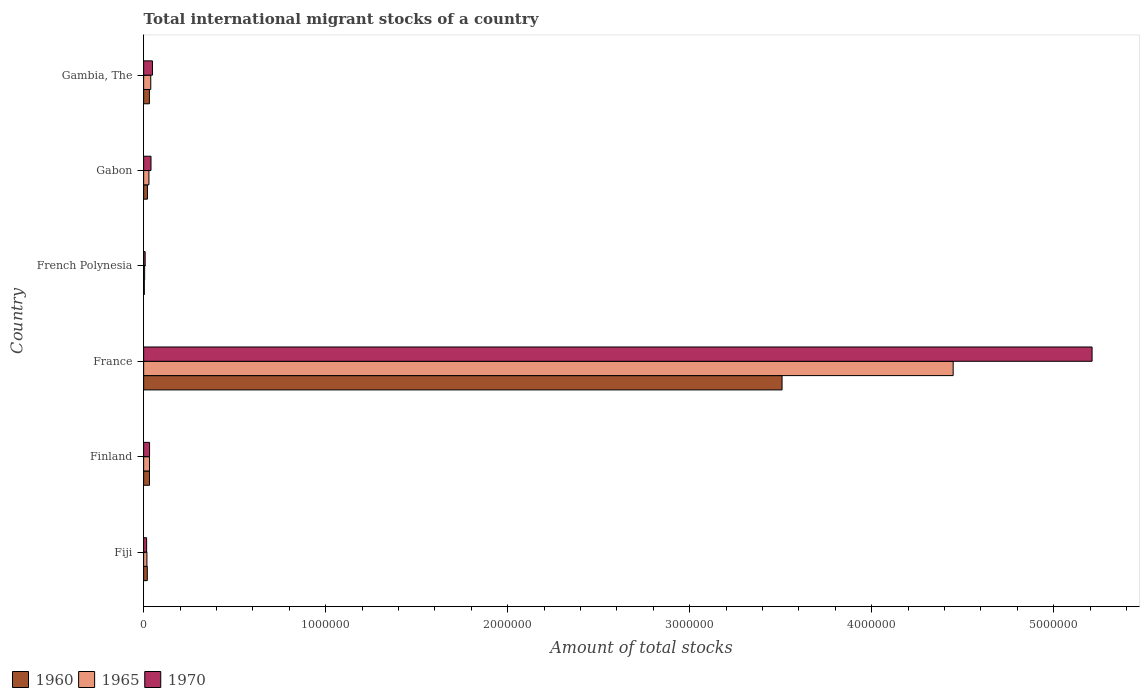How many groups of bars are there?
Ensure brevity in your answer.  6. How many bars are there on the 4th tick from the bottom?
Provide a succinct answer. 3. What is the label of the 6th group of bars from the top?
Offer a very short reply. Fiji. In how many cases, is the number of bars for a given country not equal to the number of legend labels?
Your response must be concise. 0. What is the amount of total stocks in in 1970 in Gabon?
Your answer should be very brief. 4.04e+04. Across all countries, what is the maximum amount of total stocks in in 1965?
Offer a terse response. 4.45e+06. Across all countries, what is the minimum amount of total stocks in in 1970?
Provide a succinct answer. 8194. In which country was the amount of total stocks in in 1960 maximum?
Make the answer very short. France. In which country was the amount of total stocks in in 1970 minimum?
Keep it short and to the point. French Polynesia. What is the total amount of total stocks in in 1965 in the graph?
Give a very brief answer. 4.57e+06. What is the difference between the amount of total stocks in in 1970 in Fiji and that in French Polynesia?
Make the answer very short. 8200. What is the difference between the amount of total stocks in in 1960 in Finland and the amount of total stocks in in 1970 in France?
Offer a very short reply. -5.18e+06. What is the average amount of total stocks in in 1965 per country?
Provide a short and direct response. 7.62e+05. What is the difference between the amount of total stocks in in 1965 and amount of total stocks in in 1960 in Finland?
Your answer should be very brief. 112. What is the ratio of the amount of total stocks in in 1965 in France to that in French Polynesia?
Provide a short and direct response. 811.54. Is the difference between the amount of total stocks in in 1965 in Fiji and Finland greater than the difference between the amount of total stocks in in 1960 in Fiji and Finland?
Keep it short and to the point. No. What is the difference between the highest and the second highest amount of total stocks in in 1960?
Offer a terse response. 3.48e+06. What is the difference between the highest and the lowest amount of total stocks in in 1970?
Your answer should be compact. 5.20e+06. What does the 2nd bar from the top in Gambia, The represents?
Offer a terse response. 1965. What does the 1st bar from the bottom in Finland represents?
Keep it short and to the point. 1960. Is it the case that in every country, the sum of the amount of total stocks in in 1970 and amount of total stocks in in 1960 is greater than the amount of total stocks in in 1965?
Offer a very short reply. Yes. Are all the bars in the graph horizontal?
Keep it short and to the point. Yes. What is the difference between two consecutive major ticks on the X-axis?
Make the answer very short. 1.00e+06. Are the values on the major ticks of X-axis written in scientific E-notation?
Offer a very short reply. No. Does the graph contain any zero values?
Your answer should be very brief. No. Where does the legend appear in the graph?
Your answer should be very brief. Bottom left. How are the legend labels stacked?
Your response must be concise. Horizontal. What is the title of the graph?
Offer a terse response. Total international migrant stocks of a country. Does "2010" appear as one of the legend labels in the graph?
Provide a short and direct response. No. What is the label or title of the X-axis?
Provide a succinct answer. Amount of total stocks. What is the Amount of total stocks of 1960 in Fiji?
Keep it short and to the point. 2.01e+04. What is the Amount of total stocks of 1965 in Fiji?
Make the answer very short. 1.80e+04. What is the Amount of total stocks in 1970 in Fiji?
Ensure brevity in your answer.  1.64e+04. What is the Amount of total stocks in 1960 in Finland?
Offer a very short reply. 3.21e+04. What is the Amount of total stocks in 1965 in Finland?
Your response must be concise. 3.22e+04. What is the Amount of total stocks of 1970 in Finland?
Give a very brief answer. 3.25e+04. What is the Amount of total stocks of 1960 in France?
Give a very brief answer. 3.51e+06. What is the Amount of total stocks of 1965 in France?
Keep it short and to the point. 4.45e+06. What is the Amount of total stocks of 1970 in France?
Offer a very short reply. 5.21e+06. What is the Amount of total stocks of 1960 in French Polynesia?
Ensure brevity in your answer.  3665. What is the Amount of total stocks of 1965 in French Polynesia?
Offer a terse response. 5480. What is the Amount of total stocks of 1970 in French Polynesia?
Provide a succinct answer. 8194. What is the Amount of total stocks of 1960 in Gabon?
Offer a terse response. 2.09e+04. What is the Amount of total stocks of 1965 in Gabon?
Your answer should be very brief. 2.90e+04. What is the Amount of total stocks of 1970 in Gabon?
Provide a succinct answer. 4.04e+04. What is the Amount of total stocks of 1960 in Gambia, The?
Provide a succinct answer. 3.16e+04. What is the Amount of total stocks in 1965 in Gambia, The?
Provide a short and direct response. 3.91e+04. What is the Amount of total stocks of 1970 in Gambia, The?
Offer a very short reply. 4.84e+04. Across all countries, what is the maximum Amount of total stocks in 1960?
Your answer should be very brief. 3.51e+06. Across all countries, what is the maximum Amount of total stocks in 1965?
Provide a succinct answer. 4.45e+06. Across all countries, what is the maximum Amount of total stocks in 1970?
Ensure brevity in your answer.  5.21e+06. Across all countries, what is the minimum Amount of total stocks of 1960?
Provide a succinct answer. 3665. Across all countries, what is the minimum Amount of total stocks of 1965?
Give a very brief answer. 5480. Across all countries, what is the minimum Amount of total stocks of 1970?
Give a very brief answer. 8194. What is the total Amount of total stocks of 1960 in the graph?
Make the answer very short. 3.62e+06. What is the total Amount of total stocks of 1965 in the graph?
Your answer should be very brief. 4.57e+06. What is the total Amount of total stocks in 1970 in the graph?
Your response must be concise. 5.36e+06. What is the difference between the Amount of total stocks in 1960 in Fiji and that in Finland?
Keep it short and to the point. -1.20e+04. What is the difference between the Amount of total stocks in 1965 in Fiji and that in Finland?
Provide a short and direct response. -1.42e+04. What is the difference between the Amount of total stocks of 1970 in Fiji and that in Finland?
Provide a succinct answer. -1.61e+04. What is the difference between the Amount of total stocks of 1960 in Fiji and that in France?
Give a very brief answer. -3.49e+06. What is the difference between the Amount of total stocks of 1965 in Fiji and that in France?
Your answer should be very brief. -4.43e+06. What is the difference between the Amount of total stocks of 1970 in Fiji and that in France?
Your response must be concise. -5.19e+06. What is the difference between the Amount of total stocks in 1960 in Fiji and that in French Polynesia?
Your response must be concise. 1.64e+04. What is the difference between the Amount of total stocks of 1965 in Fiji and that in French Polynesia?
Give a very brief answer. 1.25e+04. What is the difference between the Amount of total stocks of 1970 in Fiji and that in French Polynesia?
Offer a very short reply. 8200. What is the difference between the Amount of total stocks in 1960 in Fiji and that in Gabon?
Offer a very short reply. -787. What is the difference between the Amount of total stocks of 1965 in Fiji and that in Gabon?
Keep it short and to the point. -1.11e+04. What is the difference between the Amount of total stocks of 1970 in Fiji and that in Gabon?
Offer a terse response. -2.40e+04. What is the difference between the Amount of total stocks in 1960 in Fiji and that in Gambia, The?
Make the answer very short. -1.15e+04. What is the difference between the Amount of total stocks of 1965 in Fiji and that in Gambia, The?
Offer a very short reply. -2.11e+04. What is the difference between the Amount of total stocks in 1970 in Fiji and that in Gambia, The?
Provide a succinct answer. -3.20e+04. What is the difference between the Amount of total stocks in 1960 in Finland and that in France?
Your answer should be compact. -3.48e+06. What is the difference between the Amount of total stocks in 1965 in Finland and that in France?
Give a very brief answer. -4.42e+06. What is the difference between the Amount of total stocks in 1970 in Finland and that in France?
Offer a terse response. -5.18e+06. What is the difference between the Amount of total stocks in 1960 in Finland and that in French Polynesia?
Keep it short and to the point. 2.84e+04. What is the difference between the Amount of total stocks of 1965 in Finland and that in French Polynesia?
Your answer should be compact. 2.67e+04. What is the difference between the Amount of total stocks of 1970 in Finland and that in French Polynesia?
Offer a terse response. 2.43e+04. What is the difference between the Amount of total stocks in 1960 in Finland and that in Gabon?
Your answer should be very brief. 1.12e+04. What is the difference between the Amount of total stocks of 1965 in Finland and that in Gabon?
Offer a very short reply. 3166. What is the difference between the Amount of total stocks of 1970 in Finland and that in Gabon?
Offer a very short reply. -7900. What is the difference between the Amount of total stocks of 1960 in Finland and that in Gambia, The?
Your answer should be compact. 533. What is the difference between the Amount of total stocks of 1965 in Finland and that in Gambia, The?
Offer a very short reply. -6877. What is the difference between the Amount of total stocks of 1970 in Finland and that in Gambia, The?
Your response must be concise. -1.59e+04. What is the difference between the Amount of total stocks in 1960 in France and that in French Polynesia?
Offer a very short reply. 3.50e+06. What is the difference between the Amount of total stocks in 1965 in France and that in French Polynesia?
Offer a very short reply. 4.44e+06. What is the difference between the Amount of total stocks in 1970 in France and that in French Polynesia?
Your answer should be very brief. 5.20e+06. What is the difference between the Amount of total stocks of 1960 in France and that in Gabon?
Offer a very short reply. 3.49e+06. What is the difference between the Amount of total stocks in 1965 in France and that in Gabon?
Keep it short and to the point. 4.42e+06. What is the difference between the Amount of total stocks in 1970 in France and that in Gabon?
Keep it short and to the point. 5.17e+06. What is the difference between the Amount of total stocks of 1960 in France and that in Gambia, The?
Your response must be concise. 3.48e+06. What is the difference between the Amount of total stocks in 1965 in France and that in Gambia, The?
Keep it short and to the point. 4.41e+06. What is the difference between the Amount of total stocks in 1970 in France and that in Gambia, The?
Provide a short and direct response. 5.16e+06. What is the difference between the Amount of total stocks of 1960 in French Polynesia and that in Gabon?
Provide a short and direct response. -1.72e+04. What is the difference between the Amount of total stocks in 1965 in French Polynesia and that in Gabon?
Offer a very short reply. -2.36e+04. What is the difference between the Amount of total stocks of 1970 in French Polynesia and that in Gabon?
Offer a terse response. -3.22e+04. What is the difference between the Amount of total stocks of 1960 in French Polynesia and that in Gambia, The?
Make the answer very short. -2.79e+04. What is the difference between the Amount of total stocks in 1965 in French Polynesia and that in Gambia, The?
Offer a very short reply. -3.36e+04. What is the difference between the Amount of total stocks of 1970 in French Polynesia and that in Gambia, The?
Keep it short and to the point. -4.02e+04. What is the difference between the Amount of total stocks in 1960 in Gabon and that in Gambia, The?
Give a very brief answer. -1.07e+04. What is the difference between the Amount of total stocks of 1965 in Gabon and that in Gambia, The?
Make the answer very short. -1.00e+04. What is the difference between the Amount of total stocks of 1970 in Gabon and that in Gambia, The?
Your response must be concise. -7998. What is the difference between the Amount of total stocks of 1960 in Fiji and the Amount of total stocks of 1965 in Finland?
Provide a succinct answer. -1.21e+04. What is the difference between the Amount of total stocks of 1960 in Fiji and the Amount of total stocks of 1970 in Finland?
Offer a terse response. -1.24e+04. What is the difference between the Amount of total stocks of 1965 in Fiji and the Amount of total stocks of 1970 in Finland?
Make the answer very short. -1.45e+04. What is the difference between the Amount of total stocks of 1960 in Fiji and the Amount of total stocks of 1965 in France?
Provide a short and direct response. -4.43e+06. What is the difference between the Amount of total stocks in 1960 in Fiji and the Amount of total stocks in 1970 in France?
Your answer should be very brief. -5.19e+06. What is the difference between the Amount of total stocks in 1965 in Fiji and the Amount of total stocks in 1970 in France?
Provide a short and direct response. -5.19e+06. What is the difference between the Amount of total stocks of 1960 in Fiji and the Amount of total stocks of 1965 in French Polynesia?
Ensure brevity in your answer.  1.46e+04. What is the difference between the Amount of total stocks of 1960 in Fiji and the Amount of total stocks of 1970 in French Polynesia?
Ensure brevity in your answer.  1.19e+04. What is the difference between the Amount of total stocks in 1965 in Fiji and the Amount of total stocks in 1970 in French Polynesia?
Offer a very short reply. 9759. What is the difference between the Amount of total stocks in 1960 in Fiji and the Amount of total stocks in 1965 in Gabon?
Offer a terse response. -8952. What is the difference between the Amount of total stocks in 1960 in Fiji and the Amount of total stocks in 1970 in Gabon?
Keep it short and to the point. -2.03e+04. What is the difference between the Amount of total stocks in 1965 in Fiji and the Amount of total stocks in 1970 in Gabon?
Offer a very short reply. -2.24e+04. What is the difference between the Amount of total stocks of 1960 in Fiji and the Amount of total stocks of 1965 in Gambia, The?
Offer a very short reply. -1.90e+04. What is the difference between the Amount of total stocks of 1960 in Fiji and the Amount of total stocks of 1970 in Gambia, The?
Give a very brief answer. -2.83e+04. What is the difference between the Amount of total stocks in 1965 in Fiji and the Amount of total stocks in 1970 in Gambia, The?
Keep it short and to the point. -3.04e+04. What is the difference between the Amount of total stocks of 1960 in Finland and the Amount of total stocks of 1965 in France?
Make the answer very short. -4.42e+06. What is the difference between the Amount of total stocks in 1960 in Finland and the Amount of total stocks in 1970 in France?
Offer a very short reply. -5.18e+06. What is the difference between the Amount of total stocks in 1965 in Finland and the Amount of total stocks in 1970 in France?
Keep it short and to the point. -5.18e+06. What is the difference between the Amount of total stocks of 1960 in Finland and the Amount of total stocks of 1965 in French Polynesia?
Your response must be concise. 2.66e+04. What is the difference between the Amount of total stocks of 1960 in Finland and the Amount of total stocks of 1970 in French Polynesia?
Provide a succinct answer. 2.39e+04. What is the difference between the Amount of total stocks in 1965 in Finland and the Amount of total stocks in 1970 in French Polynesia?
Keep it short and to the point. 2.40e+04. What is the difference between the Amount of total stocks of 1960 in Finland and the Amount of total stocks of 1965 in Gabon?
Give a very brief answer. 3054. What is the difference between the Amount of total stocks in 1960 in Finland and the Amount of total stocks in 1970 in Gabon?
Offer a terse response. -8307. What is the difference between the Amount of total stocks in 1965 in Finland and the Amount of total stocks in 1970 in Gabon?
Your answer should be compact. -8195. What is the difference between the Amount of total stocks in 1960 in Finland and the Amount of total stocks in 1965 in Gambia, The?
Your response must be concise. -6989. What is the difference between the Amount of total stocks of 1960 in Finland and the Amount of total stocks of 1970 in Gambia, The?
Make the answer very short. -1.63e+04. What is the difference between the Amount of total stocks in 1965 in Finland and the Amount of total stocks in 1970 in Gambia, The?
Your response must be concise. -1.62e+04. What is the difference between the Amount of total stocks of 1960 in France and the Amount of total stocks of 1965 in French Polynesia?
Offer a very short reply. 3.50e+06. What is the difference between the Amount of total stocks of 1960 in France and the Amount of total stocks of 1970 in French Polynesia?
Provide a succinct answer. 3.50e+06. What is the difference between the Amount of total stocks in 1965 in France and the Amount of total stocks in 1970 in French Polynesia?
Your response must be concise. 4.44e+06. What is the difference between the Amount of total stocks in 1960 in France and the Amount of total stocks in 1965 in Gabon?
Make the answer very short. 3.48e+06. What is the difference between the Amount of total stocks in 1960 in France and the Amount of total stocks in 1970 in Gabon?
Provide a succinct answer. 3.47e+06. What is the difference between the Amount of total stocks in 1965 in France and the Amount of total stocks in 1970 in Gabon?
Offer a very short reply. 4.41e+06. What is the difference between the Amount of total stocks in 1960 in France and the Amount of total stocks in 1965 in Gambia, The?
Your response must be concise. 3.47e+06. What is the difference between the Amount of total stocks of 1960 in France and the Amount of total stocks of 1970 in Gambia, The?
Ensure brevity in your answer.  3.46e+06. What is the difference between the Amount of total stocks of 1965 in France and the Amount of total stocks of 1970 in Gambia, The?
Ensure brevity in your answer.  4.40e+06. What is the difference between the Amount of total stocks of 1960 in French Polynesia and the Amount of total stocks of 1965 in Gabon?
Offer a very short reply. -2.54e+04. What is the difference between the Amount of total stocks in 1960 in French Polynesia and the Amount of total stocks in 1970 in Gabon?
Keep it short and to the point. -3.67e+04. What is the difference between the Amount of total stocks in 1965 in French Polynesia and the Amount of total stocks in 1970 in Gabon?
Give a very brief answer. -3.49e+04. What is the difference between the Amount of total stocks in 1960 in French Polynesia and the Amount of total stocks in 1965 in Gambia, The?
Your answer should be compact. -3.54e+04. What is the difference between the Amount of total stocks in 1960 in French Polynesia and the Amount of total stocks in 1970 in Gambia, The?
Ensure brevity in your answer.  -4.47e+04. What is the difference between the Amount of total stocks in 1965 in French Polynesia and the Amount of total stocks in 1970 in Gambia, The?
Offer a very short reply. -4.29e+04. What is the difference between the Amount of total stocks in 1960 in Gabon and the Amount of total stocks in 1965 in Gambia, The?
Offer a very short reply. -1.82e+04. What is the difference between the Amount of total stocks of 1960 in Gabon and the Amount of total stocks of 1970 in Gambia, The?
Provide a succinct answer. -2.75e+04. What is the difference between the Amount of total stocks of 1965 in Gabon and the Amount of total stocks of 1970 in Gambia, The?
Provide a succinct answer. -1.94e+04. What is the average Amount of total stocks in 1960 per country?
Offer a very short reply. 6.03e+05. What is the average Amount of total stocks of 1965 per country?
Give a very brief answer. 7.62e+05. What is the average Amount of total stocks in 1970 per country?
Provide a succinct answer. 8.93e+05. What is the difference between the Amount of total stocks in 1960 and Amount of total stocks in 1965 in Fiji?
Your answer should be compact. 2125. What is the difference between the Amount of total stocks of 1960 and Amount of total stocks of 1970 in Fiji?
Ensure brevity in your answer.  3684. What is the difference between the Amount of total stocks of 1965 and Amount of total stocks of 1970 in Fiji?
Make the answer very short. 1559. What is the difference between the Amount of total stocks in 1960 and Amount of total stocks in 1965 in Finland?
Provide a short and direct response. -112. What is the difference between the Amount of total stocks in 1960 and Amount of total stocks in 1970 in Finland?
Keep it short and to the point. -407. What is the difference between the Amount of total stocks in 1965 and Amount of total stocks in 1970 in Finland?
Your response must be concise. -295. What is the difference between the Amount of total stocks in 1960 and Amount of total stocks in 1965 in France?
Make the answer very short. -9.40e+05. What is the difference between the Amount of total stocks in 1960 and Amount of total stocks in 1970 in France?
Offer a terse response. -1.70e+06. What is the difference between the Amount of total stocks of 1965 and Amount of total stocks of 1970 in France?
Your answer should be compact. -7.63e+05. What is the difference between the Amount of total stocks of 1960 and Amount of total stocks of 1965 in French Polynesia?
Provide a short and direct response. -1815. What is the difference between the Amount of total stocks of 1960 and Amount of total stocks of 1970 in French Polynesia?
Your answer should be compact. -4529. What is the difference between the Amount of total stocks in 1965 and Amount of total stocks in 1970 in French Polynesia?
Keep it short and to the point. -2714. What is the difference between the Amount of total stocks of 1960 and Amount of total stocks of 1965 in Gabon?
Provide a succinct answer. -8165. What is the difference between the Amount of total stocks in 1960 and Amount of total stocks in 1970 in Gabon?
Offer a very short reply. -1.95e+04. What is the difference between the Amount of total stocks of 1965 and Amount of total stocks of 1970 in Gabon?
Your answer should be compact. -1.14e+04. What is the difference between the Amount of total stocks in 1960 and Amount of total stocks in 1965 in Gambia, The?
Provide a short and direct response. -7522. What is the difference between the Amount of total stocks of 1960 and Amount of total stocks of 1970 in Gambia, The?
Give a very brief answer. -1.68e+04. What is the difference between the Amount of total stocks in 1965 and Amount of total stocks in 1970 in Gambia, The?
Make the answer very short. -9316. What is the ratio of the Amount of total stocks in 1960 in Fiji to that in Finland?
Your answer should be very brief. 0.63. What is the ratio of the Amount of total stocks of 1965 in Fiji to that in Finland?
Make the answer very short. 0.56. What is the ratio of the Amount of total stocks in 1970 in Fiji to that in Finland?
Offer a very short reply. 0.5. What is the ratio of the Amount of total stocks of 1960 in Fiji to that in France?
Give a very brief answer. 0.01. What is the ratio of the Amount of total stocks of 1965 in Fiji to that in France?
Your answer should be compact. 0. What is the ratio of the Amount of total stocks in 1970 in Fiji to that in France?
Offer a very short reply. 0. What is the ratio of the Amount of total stocks of 1960 in Fiji to that in French Polynesia?
Ensure brevity in your answer.  5.48. What is the ratio of the Amount of total stocks of 1965 in Fiji to that in French Polynesia?
Your answer should be very brief. 3.28. What is the ratio of the Amount of total stocks in 1970 in Fiji to that in French Polynesia?
Ensure brevity in your answer.  2. What is the ratio of the Amount of total stocks in 1960 in Fiji to that in Gabon?
Give a very brief answer. 0.96. What is the ratio of the Amount of total stocks of 1965 in Fiji to that in Gabon?
Provide a succinct answer. 0.62. What is the ratio of the Amount of total stocks in 1970 in Fiji to that in Gabon?
Ensure brevity in your answer.  0.41. What is the ratio of the Amount of total stocks in 1960 in Fiji to that in Gambia, The?
Provide a succinct answer. 0.64. What is the ratio of the Amount of total stocks in 1965 in Fiji to that in Gambia, The?
Provide a short and direct response. 0.46. What is the ratio of the Amount of total stocks of 1970 in Fiji to that in Gambia, The?
Keep it short and to the point. 0.34. What is the ratio of the Amount of total stocks in 1960 in Finland to that in France?
Make the answer very short. 0.01. What is the ratio of the Amount of total stocks of 1965 in Finland to that in France?
Offer a very short reply. 0.01. What is the ratio of the Amount of total stocks in 1970 in Finland to that in France?
Ensure brevity in your answer.  0.01. What is the ratio of the Amount of total stocks of 1960 in Finland to that in French Polynesia?
Your answer should be very brief. 8.75. What is the ratio of the Amount of total stocks of 1965 in Finland to that in French Polynesia?
Keep it short and to the point. 5.88. What is the ratio of the Amount of total stocks in 1970 in Finland to that in French Polynesia?
Make the answer very short. 3.97. What is the ratio of the Amount of total stocks of 1960 in Finland to that in Gabon?
Your answer should be compact. 1.54. What is the ratio of the Amount of total stocks of 1965 in Finland to that in Gabon?
Provide a succinct answer. 1.11. What is the ratio of the Amount of total stocks of 1970 in Finland to that in Gabon?
Give a very brief answer. 0.8. What is the ratio of the Amount of total stocks of 1960 in Finland to that in Gambia, The?
Provide a short and direct response. 1.02. What is the ratio of the Amount of total stocks in 1965 in Finland to that in Gambia, The?
Your response must be concise. 0.82. What is the ratio of the Amount of total stocks of 1970 in Finland to that in Gambia, The?
Give a very brief answer. 0.67. What is the ratio of the Amount of total stocks of 1960 in France to that in French Polynesia?
Give a very brief answer. 956.95. What is the ratio of the Amount of total stocks in 1965 in France to that in French Polynesia?
Your answer should be compact. 811.54. What is the ratio of the Amount of total stocks of 1970 in France to that in French Polynesia?
Your response must be concise. 635.87. What is the ratio of the Amount of total stocks of 1960 in France to that in Gabon?
Provide a short and direct response. 168.09. What is the ratio of the Amount of total stocks of 1965 in France to that in Gabon?
Provide a succinct answer. 153.19. What is the ratio of the Amount of total stocks in 1970 in France to that in Gabon?
Provide a short and direct response. 129. What is the ratio of the Amount of total stocks of 1960 in France to that in Gambia, The?
Make the answer very short. 111.16. What is the ratio of the Amount of total stocks of 1965 in France to that in Gambia, The?
Give a very brief answer. 113.82. What is the ratio of the Amount of total stocks in 1970 in France to that in Gambia, The?
Offer a terse response. 107.68. What is the ratio of the Amount of total stocks of 1960 in French Polynesia to that in Gabon?
Provide a short and direct response. 0.18. What is the ratio of the Amount of total stocks of 1965 in French Polynesia to that in Gabon?
Your response must be concise. 0.19. What is the ratio of the Amount of total stocks of 1970 in French Polynesia to that in Gabon?
Ensure brevity in your answer.  0.2. What is the ratio of the Amount of total stocks in 1960 in French Polynesia to that in Gambia, The?
Offer a very short reply. 0.12. What is the ratio of the Amount of total stocks in 1965 in French Polynesia to that in Gambia, The?
Keep it short and to the point. 0.14. What is the ratio of the Amount of total stocks in 1970 in French Polynesia to that in Gambia, The?
Offer a very short reply. 0.17. What is the ratio of the Amount of total stocks of 1960 in Gabon to that in Gambia, The?
Give a very brief answer. 0.66. What is the ratio of the Amount of total stocks in 1965 in Gabon to that in Gambia, The?
Make the answer very short. 0.74. What is the ratio of the Amount of total stocks of 1970 in Gabon to that in Gambia, The?
Provide a short and direct response. 0.83. What is the difference between the highest and the second highest Amount of total stocks of 1960?
Your answer should be very brief. 3.48e+06. What is the difference between the highest and the second highest Amount of total stocks in 1965?
Keep it short and to the point. 4.41e+06. What is the difference between the highest and the second highest Amount of total stocks of 1970?
Give a very brief answer. 5.16e+06. What is the difference between the highest and the lowest Amount of total stocks in 1960?
Offer a very short reply. 3.50e+06. What is the difference between the highest and the lowest Amount of total stocks of 1965?
Your answer should be compact. 4.44e+06. What is the difference between the highest and the lowest Amount of total stocks of 1970?
Offer a very short reply. 5.20e+06. 